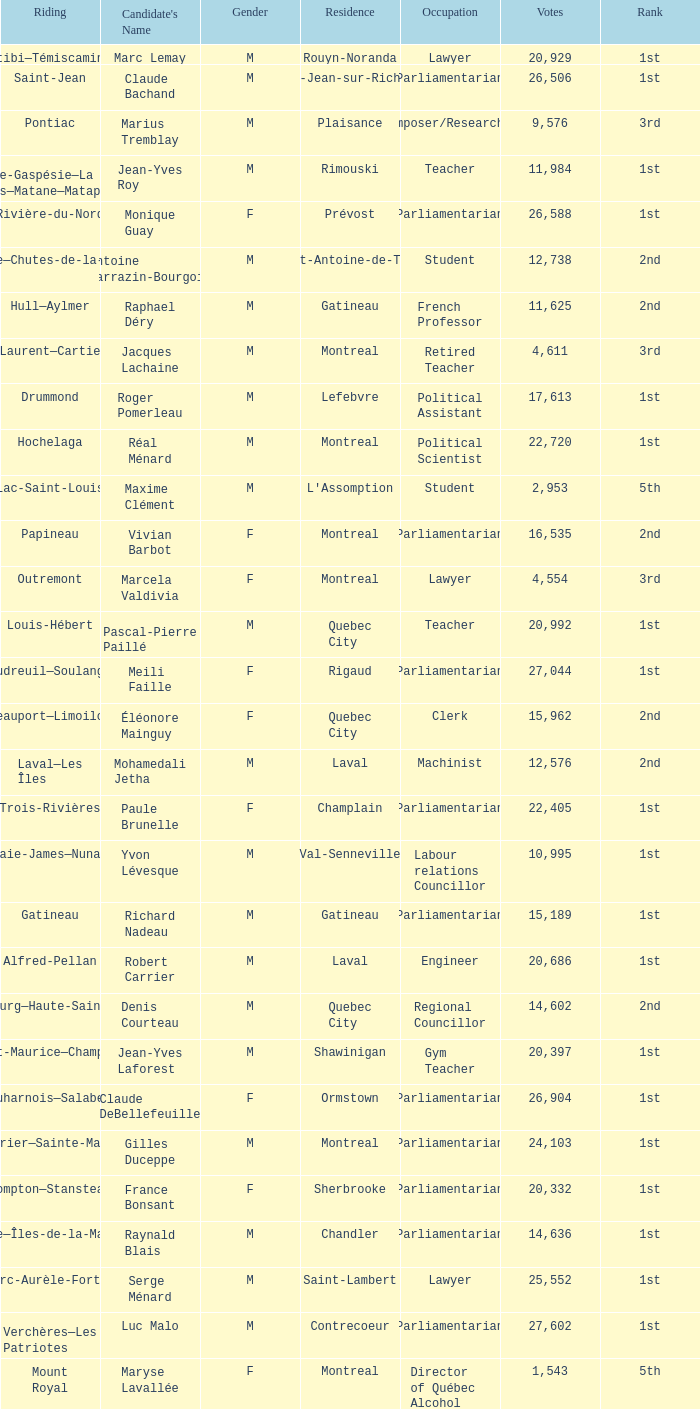What gender is Luc Desnoyers? M. 